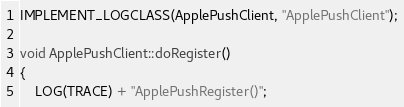<code> <loc_0><loc_0><loc_500><loc_500><_ObjectiveC_>
IMPLEMENT_LOGCLASS(ApplePushClient, "ApplePushClient");

void ApplePushClient::doRegister()
{
    LOG(TRACE) + "ApplePushRegister()";</code> 